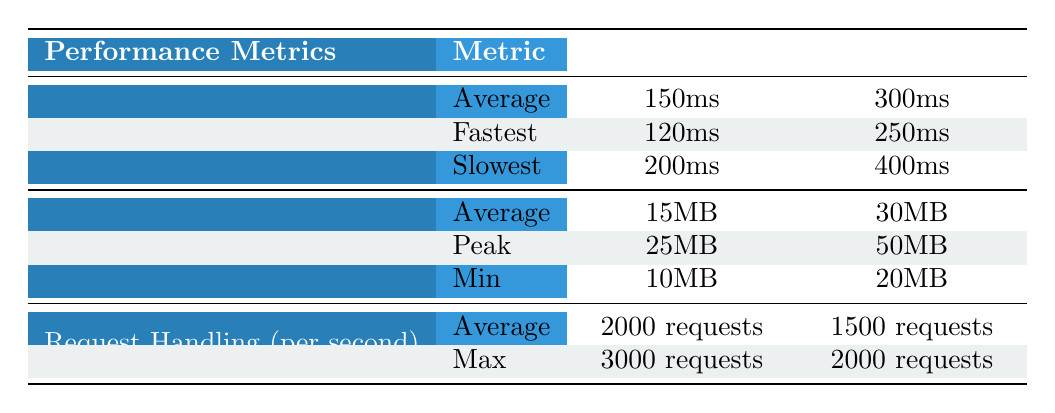What is the average startup time for Guice? The average startup time for Guice is listed directly in the table under the Startup Time metric, which shows "150ms" in the Guice column.
Answer: 150ms What is the peak memory usage for Spring? According to the table, the peak memory usage for Spring is found in the Memory Usage section, marked as "50MB" under the Spring column.
Answer: 50MB How does the fastest startup time of Guice compare to the slowest startup time of Spring? The fastest startup time for Guice is "120ms", while the slowest startup time for Spring is "400ms". Comparing these, Guice's fastest time is significantly faster than Spring's slowest time.
Answer: Guice's fastest time is faster than Spring's slowest time Is the request handling capacity for Guice higher than for Spring? The table indicates that Guice can handle "2000 requests" on average, while Spring can handle "1500 requests" on average. Therefore, Guice has a higher request handling capacity.
Answer: Yes What is the difference in average memory usage between Guice and Spring? The average memory usage for Guice is "15MB" and for Spring is "30MB". The difference is calculated as: 30MB - 15MB = 15MB.
Answer: 15MB Which dependency injection framework has the highest request handling capacity? The average request handling capacity is "2000 requests" for Guice and "1500 requests" for Spring. The comparison shows that Guice has a higher capacity than Spring.
Answer: Guice What is the average startup time difference between Guice and Spring? The average startup time for Guice is "150ms" and for Spring is "300ms". The difference is found by subtracting Guice's average from Spring's, calculated as: 300ms - 150ms = 150ms.
Answer: 150ms Is it true that the minimum memory usage for Guice is lower than that of Spring? The minimum memory usage for Guice is "10MB", and for Spring, it is "20MB". Since 10MB is less than 20MB, this statement is true.
Answer: Yes What is the maximum request handling capacity for Guice compared to the average handling capacity for Spring? Guice has a maximum request handling capacity of "3000 requests", while Spring's average is "1500 requests". Since 3000 is greater than 1500, Guice handles more requests.
Answer: Guice has a higher maximum capacity 